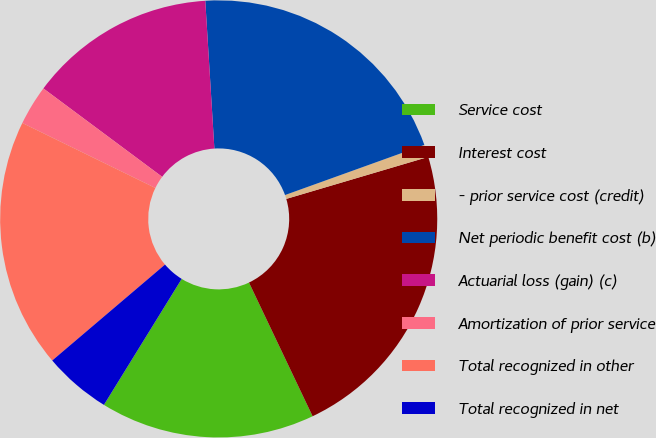Convert chart. <chart><loc_0><loc_0><loc_500><loc_500><pie_chart><fcel>Service cost<fcel>Interest cost<fcel>- prior service cost (credit)<fcel>Net periodic benefit cost (b)<fcel>Actuarial loss (gain) (c)<fcel>Amortization of prior service<fcel>Total recognized in other<fcel>Total recognized in net<nl><fcel>15.87%<fcel>22.51%<fcel>0.92%<fcel>20.48%<fcel>13.84%<fcel>2.95%<fcel>18.45%<fcel>4.98%<nl></chart> 